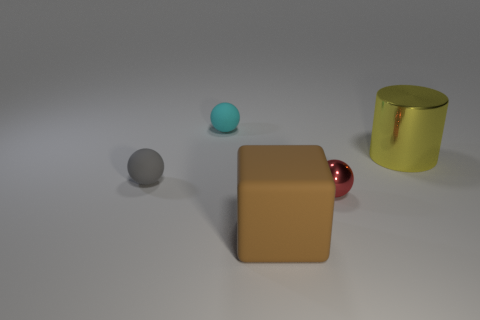Do the tiny ball that is on the right side of the brown matte block and the shiny thing that is behind the tiny metallic sphere have the same color? The small ball on the right side of the brown matte block appears to be a turquoise shade, while the shiny object behind the tiny metallic sphere has more of a golden hue. So, they do not have the same color; one is cooler and the other warmer in tone. 